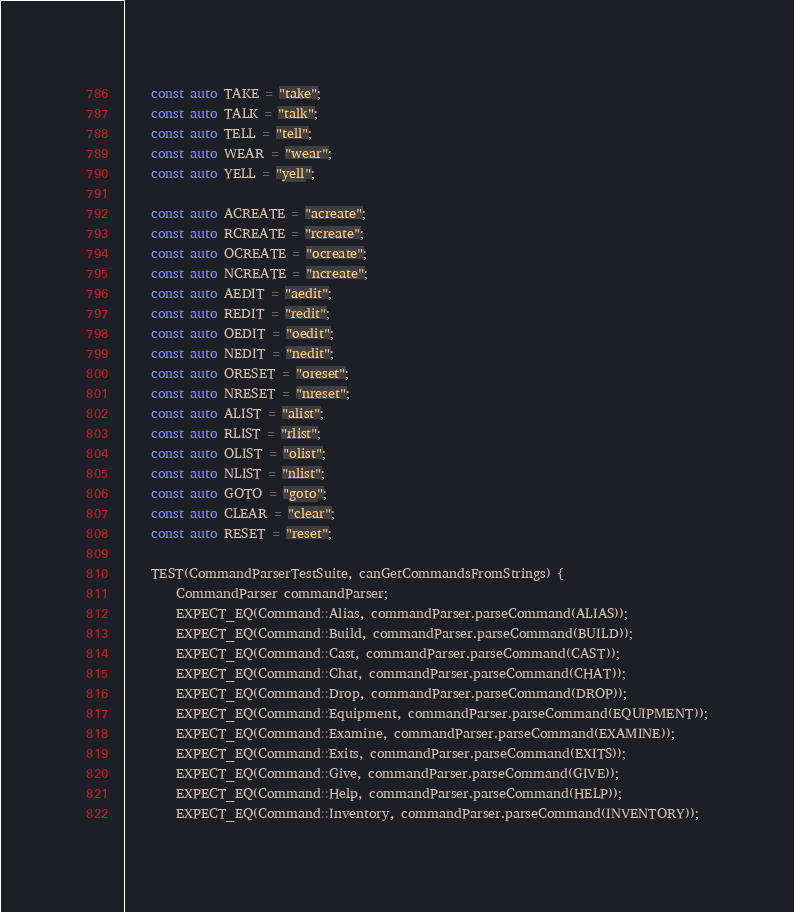<code> <loc_0><loc_0><loc_500><loc_500><_C++_>    const auto TAKE = "take";
    const auto TALK = "talk";
    const auto TELL = "tell";
    const auto WEAR = "wear";
    const auto YELL = "yell";

    const auto ACREATE = "acreate";
    const auto RCREATE = "rcreate";
    const auto OCREATE = "ocreate";
    const auto NCREATE = "ncreate";
    const auto AEDIT = "aedit";
    const auto REDIT = "redit";
    const auto OEDIT = "oedit";
    const auto NEDIT = "nedit";
    const auto ORESET = "oreset";
    const auto NRESET = "nreset";
    const auto ALIST = "alist";
    const auto RLIST = "rlist";
    const auto OLIST = "olist";
    const auto NLIST = "nlist";
    const auto GOTO = "goto";
    const auto CLEAR = "clear";
    const auto RESET = "reset";

    TEST(CommandParserTestSuite, canGetCommandsFromStrings) {
        CommandParser commandParser;
        EXPECT_EQ(Command::Alias, commandParser.parseCommand(ALIAS));
        EXPECT_EQ(Command::Build, commandParser.parseCommand(BUILD));
        EXPECT_EQ(Command::Cast, commandParser.parseCommand(CAST));
        EXPECT_EQ(Command::Chat, commandParser.parseCommand(CHAT));
        EXPECT_EQ(Command::Drop, commandParser.parseCommand(DROP));
        EXPECT_EQ(Command::Equipment, commandParser.parseCommand(EQUIPMENT));
        EXPECT_EQ(Command::Examine, commandParser.parseCommand(EXAMINE));
        EXPECT_EQ(Command::Exits, commandParser.parseCommand(EXITS));
        EXPECT_EQ(Command::Give, commandParser.parseCommand(GIVE));
        EXPECT_EQ(Command::Help, commandParser.parseCommand(HELP));
        EXPECT_EQ(Command::Inventory, commandParser.parseCommand(INVENTORY));</code> 